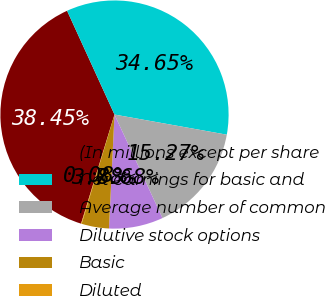Convert chart. <chart><loc_0><loc_0><loc_500><loc_500><pie_chart><fcel>(In millions except per share<fcel>Net earnings for basic and<fcel>Average number of common<fcel>Dilutive stock options<fcel>Basic<fcel>Diluted<nl><fcel>38.45%<fcel>34.65%<fcel>15.27%<fcel>7.68%<fcel>3.88%<fcel>0.08%<nl></chart> 